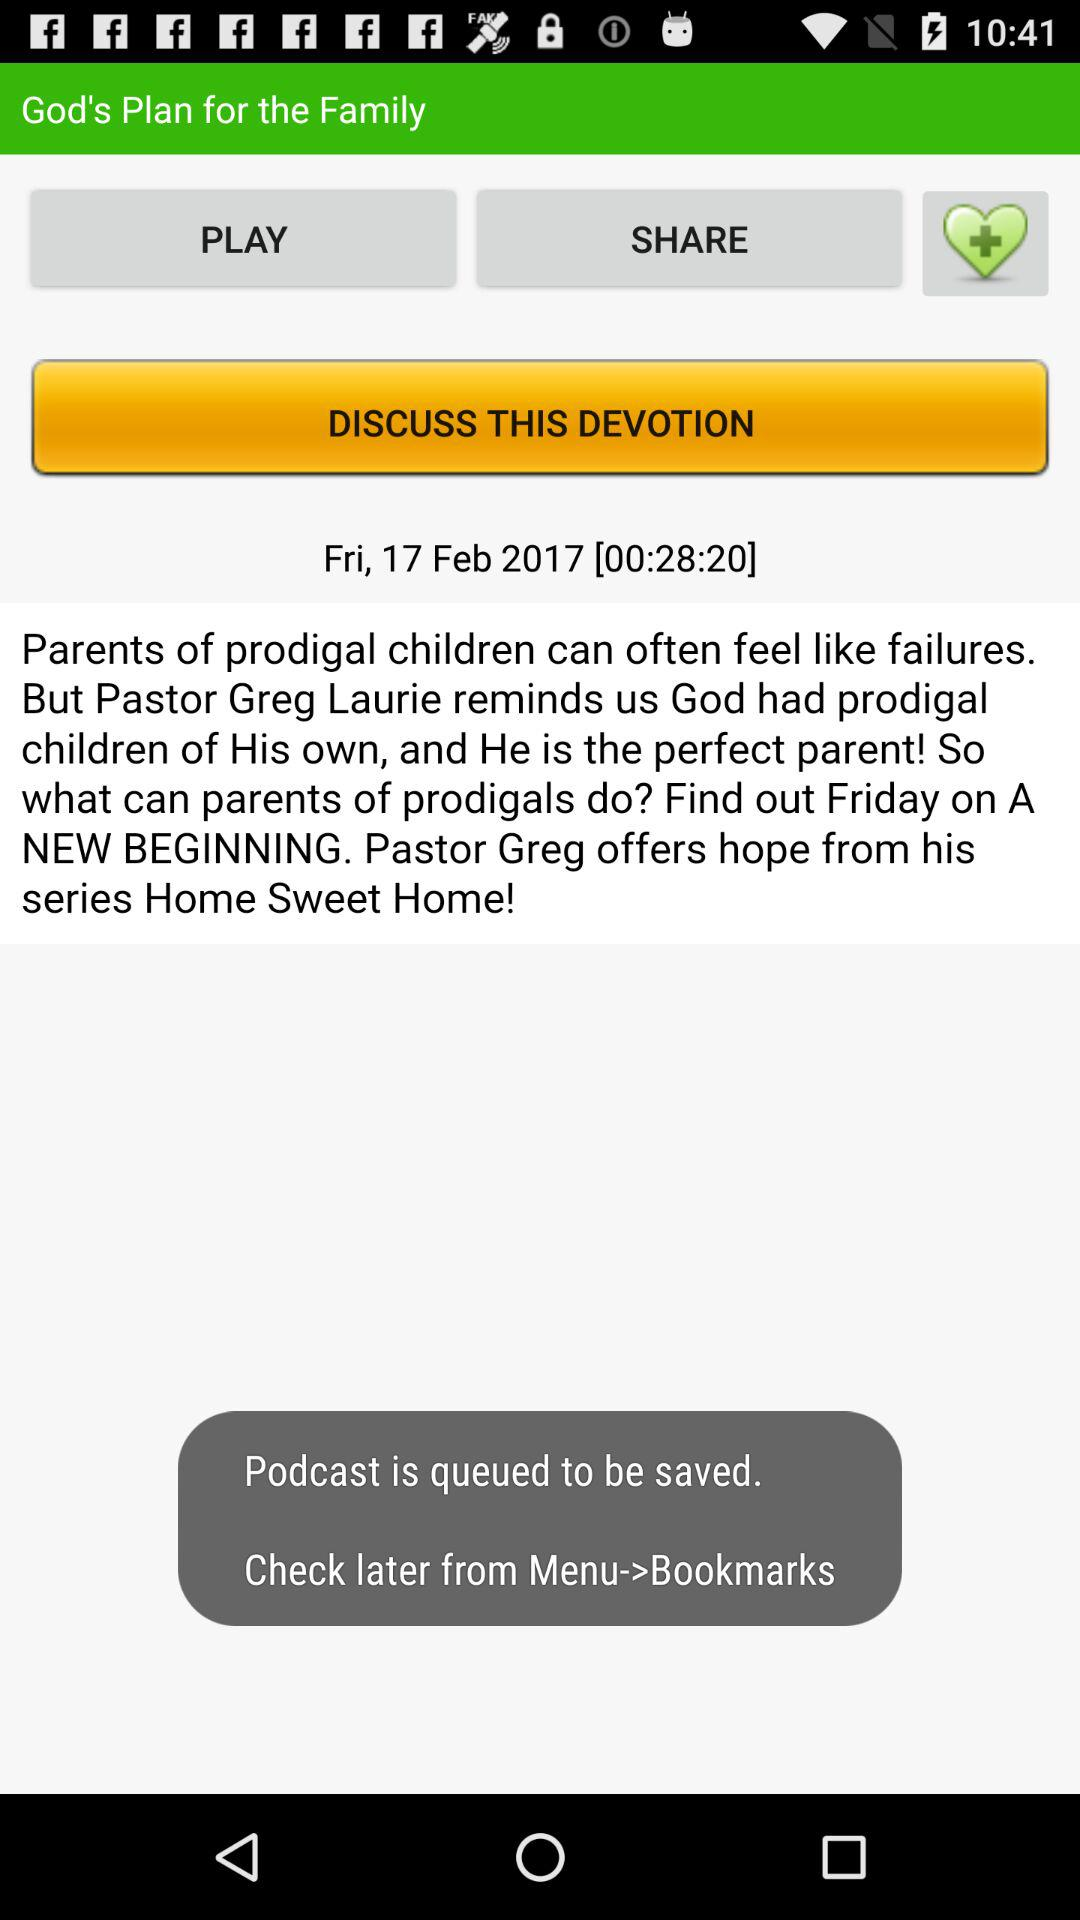What is the date of devotion? The date of devotion is Friday, 17 February, 2017. 